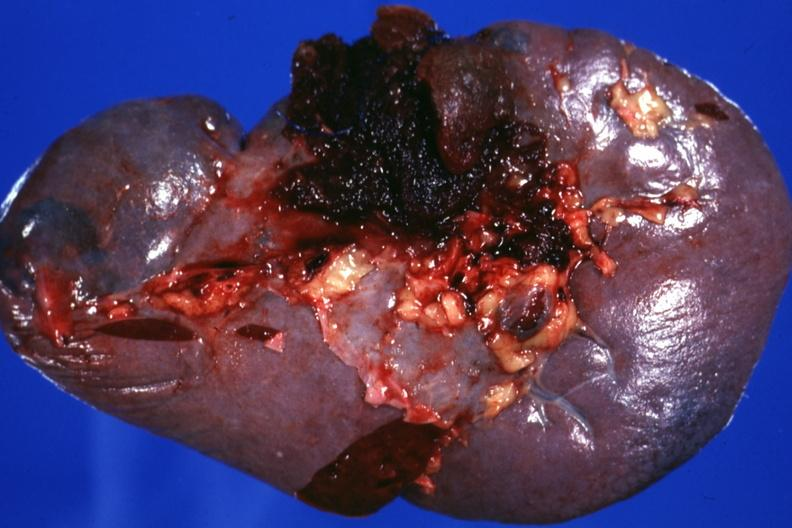s spleen present?
Answer the question using a single word or phrase. Yes 